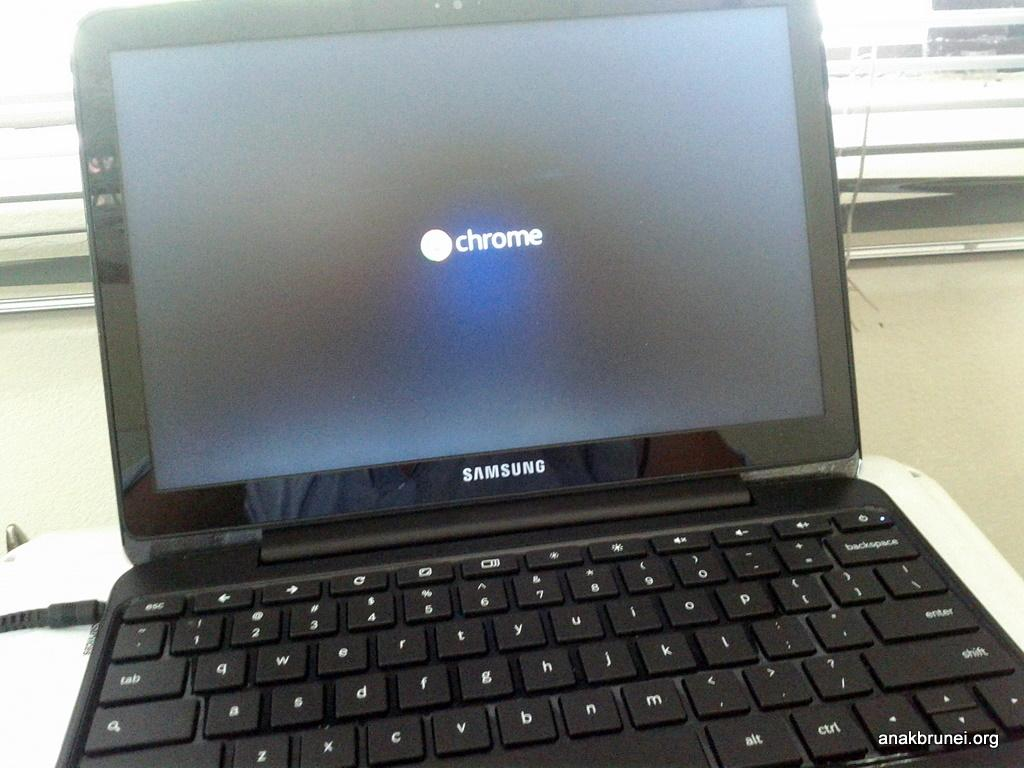Provide a one-sentence caption for the provided image. A Samsung laptop sitting on desk and the word Chrome on the screen. 